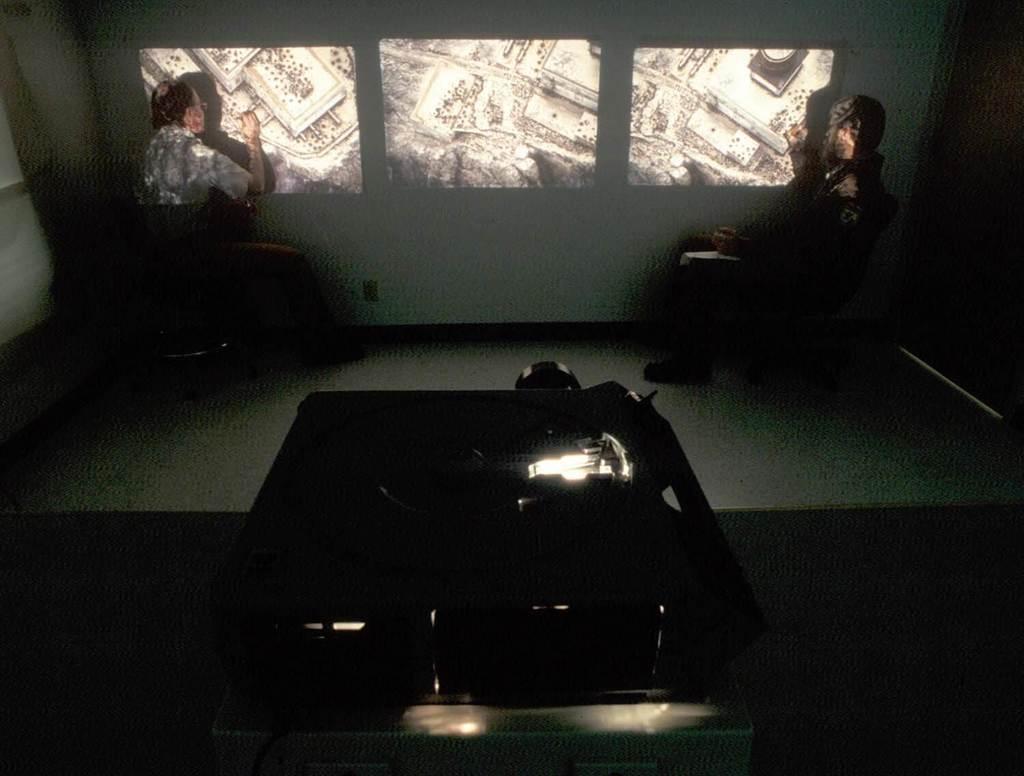How would you summarize this image in a sentence or two? In this image we can see a projector. In the back there are two persons sitting. Also there is a wall with some images. 